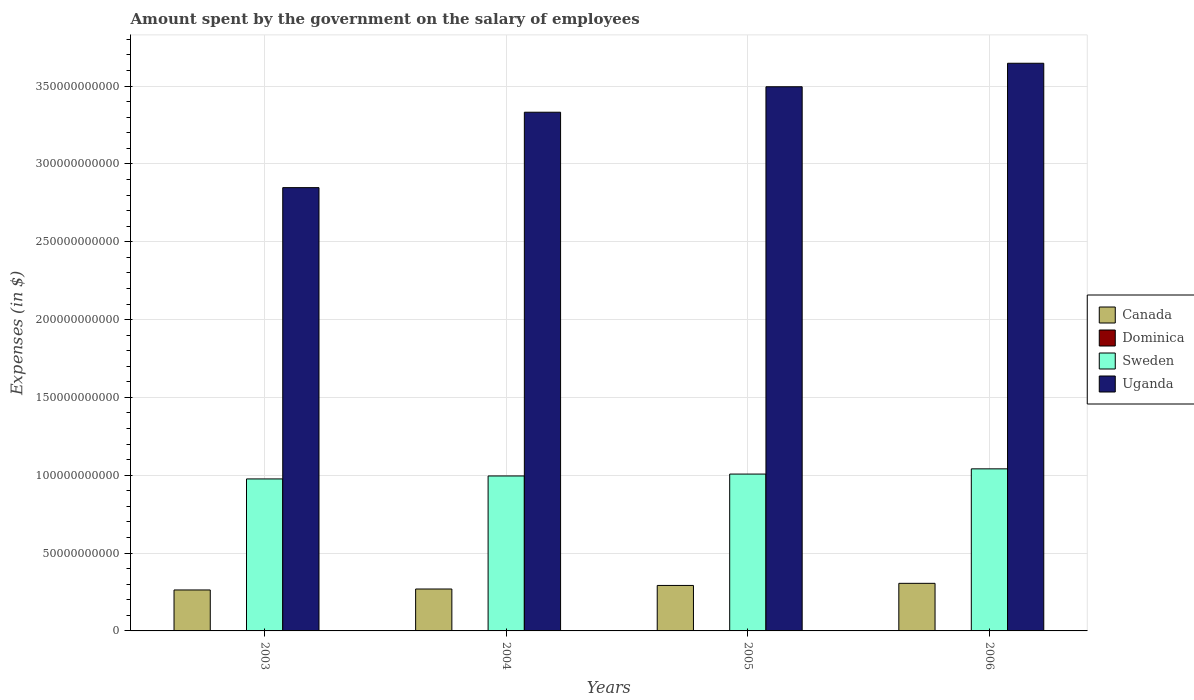Are the number of bars on each tick of the X-axis equal?
Your answer should be compact. Yes. How many bars are there on the 2nd tick from the right?
Your answer should be very brief. 4. What is the label of the 3rd group of bars from the left?
Your answer should be compact. 2005. What is the amount spent on the salary of employees by the government in Sweden in 2005?
Make the answer very short. 1.01e+11. Across all years, what is the maximum amount spent on the salary of employees by the government in Dominica?
Your answer should be compact. 1.16e+08. Across all years, what is the minimum amount spent on the salary of employees by the government in Sweden?
Offer a very short reply. 9.76e+1. In which year was the amount spent on the salary of employees by the government in Sweden maximum?
Your answer should be compact. 2006. What is the total amount spent on the salary of employees by the government in Uganda in the graph?
Keep it short and to the point. 1.33e+12. What is the difference between the amount spent on the salary of employees by the government in Uganda in 2003 and that in 2006?
Keep it short and to the point. -7.99e+1. What is the difference between the amount spent on the salary of employees by the government in Sweden in 2003 and the amount spent on the salary of employees by the government in Canada in 2004?
Offer a terse response. 7.07e+1. What is the average amount spent on the salary of employees by the government in Sweden per year?
Provide a short and direct response. 1.01e+11. In the year 2005, what is the difference between the amount spent on the salary of employees by the government in Dominica and amount spent on the salary of employees by the government in Uganda?
Ensure brevity in your answer.  -3.49e+11. What is the ratio of the amount spent on the salary of employees by the government in Canada in 2005 to that in 2006?
Ensure brevity in your answer.  0.96. Is the amount spent on the salary of employees by the government in Canada in 2004 less than that in 2006?
Ensure brevity in your answer.  Yes. What is the difference between the highest and the second highest amount spent on the salary of employees by the government in Dominica?
Ensure brevity in your answer.  6.00e+06. What is the difference between the highest and the lowest amount spent on the salary of employees by the government in Uganda?
Your answer should be very brief. 7.99e+1. Is the sum of the amount spent on the salary of employees by the government in Dominica in 2003 and 2005 greater than the maximum amount spent on the salary of employees by the government in Uganda across all years?
Your answer should be very brief. No. What does the 4th bar from the left in 2005 represents?
Offer a terse response. Uganda. What does the 3rd bar from the right in 2006 represents?
Ensure brevity in your answer.  Dominica. How many bars are there?
Give a very brief answer. 16. Are all the bars in the graph horizontal?
Keep it short and to the point. No. What is the difference between two consecutive major ticks on the Y-axis?
Make the answer very short. 5.00e+1. Are the values on the major ticks of Y-axis written in scientific E-notation?
Make the answer very short. No. How are the legend labels stacked?
Offer a terse response. Vertical. What is the title of the graph?
Your response must be concise. Amount spent by the government on the salary of employees. Does "Togo" appear as one of the legend labels in the graph?
Your answer should be very brief. No. What is the label or title of the X-axis?
Give a very brief answer. Years. What is the label or title of the Y-axis?
Your answer should be very brief. Expenses (in $). What is the Expenses (in $) in Canada in 2003?
Offer a very short reply. 2.63e+1. What is the Expenses (in $) in Dominica in 2003?
Provide a succinct answer. 1.16e+08. What is the Expenses (in $) in Sweden in 2003?
Offer a terse response. 9.76e+1. What is the Expenses (in $) of Uganda in 2003?
Your response must be concise. 2.85e+11. What is the Expenses (in $) in Canada in 2004?
Offer a very short reply. 2.69e+1. What is the Expenses (in $) of Dominica in 2004?
Ensure brevity in your answer.  1.09e+08. What is the Expenses (in $) of Sweden in 2004?
Provide a succinct answer. 9.95e+1. What is the Expenses (in $) in Uganda in 2004?
Provide a short and direct response. 3.33e+11. What is the Expenses (in $) in Canada in 2005?
Provide a succinct answer. 2.92e+1. What is the Expenses (in $) of Dominica in 2005?
Provide a succinct answer. 1.08e+08. What is the Expenses (in $) of Sweden in 2005?
Give a very brief answer. 1.01e+11. What is the Expenses (in $) in Uganda in 2005?
Your answer should be compact. 3.50e+11. What is the Expenses (in $) in Canada in 2006?
Provide a short and direct response. 3.06e+1. What is the Expenses (in $) in Dominica in 2006?
Keep it short and to the point. 1.10e+08. What is the Expenses (in $) of Sweden in 2006?
Keep it short and to the point. 1.04e+11. What is the Expenses (in $) in Uganda in 2006?
Provide a short and direct response. 3.65e+11. Across all years, what is the maximum Expenses (in $) of Canada?
Ensure brevity in your answer.  3.06e+1. Across all years, what is the maximum Expenses (in $) of Dominica?
Provide a short and direct response. 1.16e+08. Across all years, what is the maximum Expenses (in $) of Sweden?
Offer a terse response. 1.04e+11. Across all years, what is the maximum Expenses (in $) in Uganda?
Provide a succinct answer. 3.65e+11. Across all years, what is the minimum Expenses (in $) in Canada?
Your answer should be very brief. 2.63e+1. Across all years, what is the minimum Expenses (in $) in Dominica?
Provide a short and direct response. 1.08e+08. Across all years, what is the minimum Expenses (in $) of Sweden?
Offer a very short reply. 9.76e+1. Across all years, what is the minimum Expenses (in $) in Uganda?
Provide a short and direct response. 2.85e+11. What is the total Expenses (in $) in Canada in the graph?
Offer a very short reply. 1.13e+11. What is the total Expenses (in $) in Dominica in the graph?
Make the answer very short. 4.43e+08. What is the total Expenses (in $) in Sweden in the graph?
Ensure brevity in your answer.  4.02e+11. What is the total Expenses (in $) in Uganda in the graph?
Keep it short and to the point. 1.33e+12. What is the difference between the Expenses (in $) of Canada in 2003 and that in 2004?
Keep it short and to the point. -6.14e+08. What is the difference between the Expenses (in $) of Dominica in 2003 and that in 2004?
Offer a very short reply. 6.30e+06. What is the difference between the Expenses (in $) in Sweden in 2003 and that in 2004?
Provide a succinct answer. -1.91e+09. What is the difference between the Expenses (in $) in Uganda in 2003 and that in 2004?
Offer a very short reply. -4.84e+1. What is the difference between the Expenses (in $) of Canada in 2003 and that in 2005?
Your answer should be very brief. -2.90e+09. What is the difference between the Expenses (in $) of Dominica in 2003 and that in 2005?
Your answer should be very brief. 7.10e+06. What is the difference between the Expenses (in $) of Sweden in 2003 and that in 2005?
Your answer should be very brief. -3.12e+09. What is the difference between the Expenses (in $) in Uganda in 2003 and that in 2005?
Offer a terse response. -6.48e+1. What is the difference between the Expenses (in $) in Canada in 2003 and that in 2006?
Offer a very short reply. -4.26e+09. What is the difference between the Expenses (in $) of Sweden in 2003 and that in 2006?
Offer a very short reply. -6.48e+09. What is the difference between the Expenses (in $) of Uganda in 2003 and that in 2006?
Your answer should be very brief. -7.99e+1. What is the difference between the Expenses (in $) of Canada in 2004 and that in 2005?
Provide a short and direct response. -2.29e+09. What is the difference between the Expenses (in $) in Sweden in 2004 and that in 2005?
Provide a short and direct response. -1.21e+09. What is the difference between the Expenses (in $) of Uganda in 2004 and that in 2005?
Your answer should be compact. -1.64e+1. What is the difference between the Expenses (in $) in Canada in 2004 and that in 2006?
Make the answer very short. -3.65e+09. What is the difference between the Expenses (in $) of Dominica in 2004 and that in 2006?
Your answer should be compact. -3.00e+05. What is the difference between the Expenses (in $) in Sweden in 2004 and that in 2006?
Offer a very short reply. -4.57e+09. What is the difference between the Expenses (in $) in Uganda in 2004 and that in 2006?
Your response must be concise. -3.15e+1. What is the difference between the Expenses (in $) of Canada in 2005 and that in 2006?
Keep it short and to the point. -1.36e+09. What is the difference between the Expenses (in $) of Dominica in 2005 and that in 2006?
Offer a terse response. -1.10e+06. What is the difference between the Expenses (in $) in Sweden in 2005 and that in 2006?
Offer a very short reply. -3.36e+09. What is the difference between the Expenses (in $) of Uganda in 2005 and that in 2006?
Make the answer very short. -1.51e+1. What is the difference between the Expenses (in $) of Canada in 2003 and the Expenses (in $) of Dominica in 2004?
Ensure brevity in your answer.  2.62e+1. What is the difference between the Expenses (in $) in Canada in 2003 and the Expenses (in $) in Sweden in 2004?
Your answer should be compact. -7.32e+1. What is the difference between the Expenses (in $) of Canada in 2003 and the Expenses (in $) of Uganda in 2004?
Your response must be concise. -3.07e+11. What is the difference between the Expenses (in $) of Dominica in 2003 and the Expenses (in $) of Sweden in 2004?
Provide a short and direct response. -9.94e+1. What is the difference between the Expenses (in $) in Dominica in 2003 and the Expenses (in $) in Uganda in 2004?
Your response must be concise. -3.33e+11. What is the difference between the Expenses (in $) of Sweden in 2003 and the Expenses (in $) of Uganda in 2004?
Keep it short and to the point. -2.36e+11. What is the difference between the Expenses (in $) in Canada in 2003 and the Expenses (in $) in Dominica in 2005?
Give a very brief answer. 2.62e+1. What is the difference between the Expenses (in $) in Canada in 2003 and the Expenses (in $) in Sweden in 2005?
Ensure brevity in your answer.  -7.44e+1. What is the difference between the Expenses (in $) of Canada in 2003 and the Expenses (in $) of Uganda in 2005?
Your response must be concise. -3.23e+11. What is the difference between the Expenses (in $) in Dominica in 2003 and the Expenses (in $) in Sweden in 2005?
Your answer should be very brief. -1.01e+11. What is the difference between the Expenses (in $) in Dominica in 2003 and the Expenses (in $) in Uganda in 2005?
Offer a very short reply. -3.49e+11. What is the difference between the Expenses (in $) of Sweden in 2003 and the Expenses (in $) of Uganda in 2005?
Ensure brevity in your answer.  -2.52e+11. What is the difference between the Expenses (in $) of Canada in 2003 and the Expenses (in $) of Dominica in 2006?
Offer a very short reply. 2.62e+1. What is the difference between the Expenses (in $) of Canada in 2003 and the Expenses (in $) of Sweden in 2006?
Make the answer very short. -7.78e+1. What is the difference between the Expenses (in $) in Canada in 2003 and the Expenses (in $) in Uganda in 2006?
Offer a very short reply. -3.38e+11. What is the difference between the Expenses (in $) of Dominica in 2003 and the Expenses (in $) of Sweden in 2006?
Provide a short and direct response. -1.04e+11. What is the difference between the Expenses (in $) in Dominica in 2003 and the Expenses (in $) in Uganda in 2006?
Ensure brevity in your answer.  -3.65e+11. What is the difference between the Expenses (in $) of Sweden in 2003 and the Expenses (in $) of Uganda in 2006?
Your answer should be very brief. -2.67e+11. What is the difference between the Expenses (in $) in Canada in 2004 and the Expenses (in $) in Dominica in 2005?
Make the answer very short. 2.68e+1. What is the difference between the Expenses (in $) of Canada in 2004 and the Expenses (in $) of Sweden in 2005?
Your answer should be compact. -7.38e+1. What is the difference between the Expenses (in $) in Canada in 2004 and the Expenses (in $) in Uganda in 2005?
Your answer should be compact. -3.23e+11. What is the difference between the Expenses (in $) in Dominica in 2004 and the Expenses (in $) in Sweden in 2005?
Offer a very short reply. -1.01e+11. What is the difference between the Expenses (in $) in Dominica in 2004 and the Expenses (in $) in Uganda in 2005?
Ensure brevity in your answer.  -3.49e+11. What is the difference between the Expenses (in $) of Sweden in 2004 and the Expenses (in $) of Uganda in 2005?
Ensure brevity in your answer.  -2.50e+11. What is the difference between the Expenses (in $) in Canada in 2004 and the Expenses (in $) in Dominica in 2006?
Your answer should be compact. 2.68e+1. What is the difference between the Expenses (in $) of Canada in 2004 and the Expenses (in $) of Sweden in 2006?
Ensure brevity in your answer.  -7.72e+1. What is the difference between the Expenses (in $) of Canada in 2004 and the Expenses (in $) of Uganda in 2006?
Provide a succinct answer. -3.38e+11. What is the difference between the Expenses (in $) of Dominica in 2004 and the Expenses (in $) of Sweden in 2006?
Provide a short and direct response. -1.04e+11. What is the difference between the Expenses (in $) of Dominica in 2004 and the Expenses (in $) of Uganda in 2006?
Your response must be concise. -3.65e+11. What is the difference between the Expenses (in $) of Sweden in 2004 and the Expenses (in $) of Uganda in 2006?
Make the answer very short. -2.65e+11. What is the difference between the Expenses (in $) in Canada in 2005 and the Expenses (in $) in Dominica in 2006?
Ensure brevity in your answer.  2.91e+1. What is the difference between the Expenses (in $) in Canada in 2005 and the Expenses (in $) in Sweden in 2006?
Provide a short and direct response. -7.49e+1. What is the difference between the Expenses (in $) in Canada in 2005 and the Expenses (in $) in Uganda in 2006?
Your answer should be very brief. -3.35e+11. What is the difference between the Expenses (in $) of Dominica in 2005 and the Expenses (in $) of Sweden in 2006?
Your answer should be very brief. -1.04e+11. What is the difference between the Expenses (in $) of Dominica in 2005 and the Expenses (in $) of Uganda in 2006?
Provide a succinct answer. -3.65e+11. What is the difference between the Expenses (in $) in Sweden in 2005 and the Expenses (in $) in Uganda in 2006?
Provide a succinct answer. -2.64e+11. What is the average Expenses (in $) in Canada per year?
Your response must be concise. 2.83e+1. What is the average Expenses (in $) of Dominica per year?
Offer a very short reply. 1.11e+08. What is the average Expenses (in $) of Sweden per year?
Give a very brief answer. 1.01e+11. What is the average Expenses (in $) of Uganda per year?
Keep it short and to the point. 3.33e+11. In the year 2003, what is the difference between the Expenses (in $) in Canada and Expenses (in $) in Dominica?
Keep it short and to the point. 2.62e+1. In the year 2003, what is the difference between the Expenses (in $) of Canada and Expenses (in $) of Sweden?
Make the answer very short. -7.13e+1. In the year 2003, what is the difference between the Expenses (in $) of Canada and Expenses (in $) of Uganda?
Provide a succinct answer. -2.58e+11. In the year 2003, what is the difference between the Expenses (in $) of Dominica and Expenses (in $) of Sweden?
Your response must be concise. -9.75e+1. In the year 2003, what is the difference between the Expenses (in $) of Dominica and Expenses (in $) of Uganda?
Make the answer very short. -2.85e+11. In the year 2003, what is the difference between the Expenses (in $) of Sweden and Expenses (in $) of Uganda?
Give a very brief answer. -1.87e+11. In the year 2004, what is the difference between the Expenses (in $) in Canada and Expenses (in $) in Dominica?
Your answer should be compact. 2.68e+1. In the year 2004, what is the difference between the Expenses (in $) of Canada and Expenses (in $) of Sweden?
Keep it short and to the point. -7.26e+1. In the year 2004, what is the difference between the Expenses (in $) of Canada and Expenses (in $) of Uganda?
Ensure brevity in your answer.  -3.06e+11. In the year 2004, what is the difference between the Expenses (in $) in Dominica and Expenses (in $) in Sweden?
Your response must be concise. -9.94e+1. In the year 2004, what is the difference between the Expenses (in $) of Dominica and Expenses (in $) of Uganda?
Make the answer very short. -3.33e+11. In the year 2004, what is the difference between the Expenses (in $) in Sweden and Expenses (in $) in Uganda?
Ensure brevity in your answer.  -2.34e+11. In the year 2005, what is the difference between the Expenses (in $) in Canada and Expenses (in $) in Dominica?
Give a very brief answer. 2.91e+1. In the year 2005, what is the difference between the Expenses (in $) of Canada and Expenses (in $) of Sweden?
Your response must be concise. -7.15e+1. In the year 2005, what is the difference between the Expenses (in $) in Canada and Expenses (in $) in Uganda?
Offer a very short reply. -3.20e+11. In the year 2005, what is the difference between the Expenses (in $) of Dominica and Expenses (in $) of Sweden?
Provide a succinct answer. -1.01e+11. In the year 2005, what is the difference between the Expenses (in $) of Dominica and Expenses (in $) of Uganda?
Your answer should be very brief. -3.49e+11. In the year 2005, what is the difference between the Expenses (in $) of Sweden and Expenses (in $) of Uganda?
Your response must be concise. -2.49e+11. In the year 2006, what is the difference between the Expenses (in $) of Canada and Expenses (in $) of Dominica?
Give a very brief answer. 3.05e+1. In the year 2006, what is the difference between the Expenses (in $) of Canada and Expenses (in $) of Sweden?
Offer a very short reply. -7.35e+1. In the year 2006, what is the difference between the Expenses (in $) in Canada and Expenses (in $) in Uganda?
Give a very brief answer. -3.34e+11. In the year 2006, what is the difference between the Expenses (in $) in Dominica and Expenses (in $) in Sweden?
Give a very brief answer. -1.04e+11. In the year 2006, what is the difference between the Expenses (in $) in Dominica and Expenses (in $) in Uganda?
Make the answer very short. -3.65e+11. In the year 2006, what is the difference between the Expenses (in $) in Sweden and Expenses (in $) in Uganda?
Offer a terse response. -2.61e+11. What is the ratio of the Expenses (in $) of Canada in 2003 to that in 2004?
Your answer should be compact. 0.98. What is the ratio of the Expenses (in $) in Dominica in 2003 to that in 2004?
Make the answer very short. 1.06. What is the ratio of the Expenses (in $) of Sweden in 2003 to that in 2004?
Ensure brevity in your answer.  0.98. What is the ratio of the Expenses (in $) of Uganda in 2003 to that in 2004?
Your answer should be compact. 0.85. What is the ratio of the Expenses (in $) in Canada in 2003 to that in 2005?
Provide a short and direct response. 0.9. What is the ratio of the Expenses (in $) in Dominica in 2003 to that in 2005?
Offer a terse response. 1.07. What is the ratio of the Expenses (in $) of Sweden in 2003 to that in 2005?
Offer a terse response. 0.97. What is the ratio of the Expenses (in $) in Uganda in 2003 to that in 2005?
Offer a very short reply. 0.81. What is the ratio of the Expenses (in $) of Canada in 2003 to that in 2006?
Ensure brevity in your answer.  0.86. What is the ratio of the Expenses (in $) in Dominica in 2003 to that in 2006?
Your answer should be compact. 1.05. What is the ratio of the Expenses (in $) in Sweden in 2003 to that in 2006?
Ensure brevity in your answer.  0.94. What is the ratio of the Expenses (in $) of Uganda in 2003 to that in 2006?
Make the answer very short. 0.78. What is the ratio of the Expenses (in $) of Canada in 2004 to that in 2005?
Your answer should be compact. 0.92. What is the ratio of the Expenses (in $) of Dominica in 2004 to that in 2005?
Offer a terse response. 1.01. What is the ratio of the Expenses (in $) in Uganda in 2004 to that in 2005?
Your response must be concise. 0.95. What is the ratio of the Expenses (in $) in Canada in 2004 to that in 2006?
Provide a succinct answer. 0.88. What is the ratio of the Expenses (in $) of Dominica in 2004 to that in 2006?
Provide a succinct answer. 1. What is the ratio of the Expenses (in $) in Sweden in 2004 to that in 2006?
Offer a terse response. 0.96. What is the ratio of the Expenses (in $) in Uganda in 2004 to that in 2006?
Make the answer very short. 0.91. What is the ratio of the Expenses (in $) in Canada in 2005 to that in 2006?
Your response must be concise. 0.96. What is the ratio of the Expenses (in $) of Dominica in 2005 to that in 2006?
Your answer should be compact. 0.99. What is the ratio of the Expenses (in $) in Uganda in 2005 to that in 2006?
Offer a terse response. 0.96. What is the difference between the highest and the second highest Expenses (in $) of Canada?
Your answer should be compact. 1.36e+09. What is the difference between the highest and the second highest Expenses (in $) in Dominica?
Offer a very short reply. 6.00e+06. What is the difference between the highest and the second highest Expenses (in $) of Sweden?
Keep it short and to the point. 3.36e+09. What is the difference between the highest and the second highest Expenses (in $) in Uganda?
Provide a short and direct response. 1.51e+1. What is the difference between the highest and the lowest Expenses (in $) in Canada?
Make the answer very short. 4.26e+09. What is the difference between the highest and the lowest Expenses (in $) in Dominica?
Offer a terse response. 7.10e+06. What is the difference between the highest and the lowest Expenses (in $) in Sweden?
Make the answer very short. 6.48e+09. What is the difference between the highest and the lowest Expenses (in $) of Uganda?
Your response must be concise. 7.99e+1. 